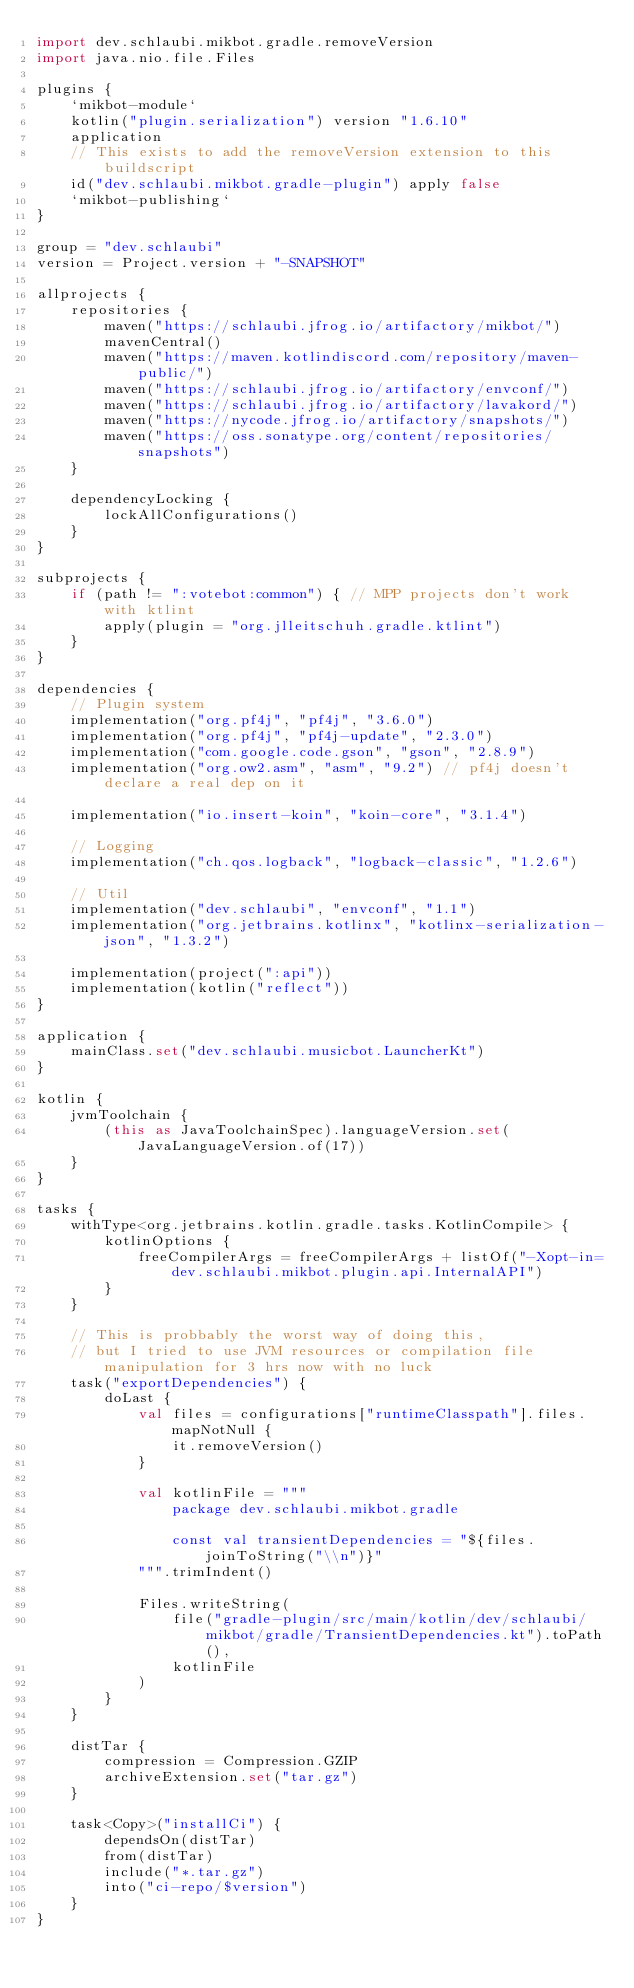<code> <loc_0><loc_0><loc_500><loc_500><_Kotlin_>import dev.schlaubi.mikbot.gradle.removeVersion
import java.nio.file.Files

plugins {
    `mikbot-module`
    kotlin("plugin.serialization") version "1.6.10"
    application
    // This exists to add the removeVersion extension to this buildscript
    id("dev.schlaubi.mikbot.gradle-plugin") apply false
    `mikbot-publishing`
}

group = "dev.schlaubi"
version = Project.version + "-SNAPSHOT"

allprojects {
    repositories {
        maven("https://schlaubi.jfrog.io/artifactory/mikbot/")
        mavenCentral()
        maven("https://maven.kotlindiscord.com/repository/maven-public/")
        maven("https://schlaubi.jfrog.io/artifactory/envconf/")
        maven("https://schlaubi.jfrog.io/artifactory/lavakord/")
        maven("https://nycode.jfrog.io/artifactory/snapshots/")
        maven("https://oss.sonatype.org/content/repositories/snapshots")
    }

    dependencyLocking {
        lockAllConfigurations()
    }
}

subprojects {
    if (path != ":votebot:common") { // MPP projects don't work with ktlint
        apply(plugin = "org.jlleitschuh.gradle.ktlint")
    }
}

dependencies {
    // Plugin system
    implementation("org.pf4j", "pf4j", "3.6.0")
    implementation("org.pf4j", "pf4j-update", "2.3.0")
    implementation("com.google.code.gson", "gson", "2.8.9")
    implementation("org.ow2.asm", "asm", "9.2") // pf4j doesn't declare a real dep on it

    implementation("io.insert-koin", "koin-core", "3.1.4")

    // Logging
    implementation("ch.qos.logback", "logback-classic", "1.2.6")

    // Util
    implementation("dev.schlaubi", "envconf", "1.1")
    implementation("org.jetbrains.kotlinx", "kotlinx-serialization-json", "1.3.2")

    implementation(project(":api"))
    implementation(kotlin("reflect"))
}

application {
    mainClass.set("dev.schlaubi.musicbot.LauncherKt")
}

kotlin {
    jvmToolchain {
        (this as JavaToolchainSpec).languageVersion.set(JavaLanguageVersion.of(17))
    }
}

tasks {
    withType<org.jetbrains.kotlin.gradle.tasks.KotlinCompile> {
        kotlinOptions {
            freeCompilerArgs = freeCompilerArgs + listOf("-Xopt-in=dev.schlaubi.mikbot.plugin.api.InternalAPI")
        }
    }

    // This is probbably the worst way of doing this,
    // but I tried to use JVM resources or compilation file manipulation for 3 hrs now with no luck
    task("exportDependencies") {
        doLast {
            val files = configurations["runtimeClasspath"].files.mapNotNull {
                it.removeVersion()
            }

            val kotlinFile = """
                package dev.schlaubi.mikbot.gradle
                
                const val transientDependencies = "${files.joinToString("\\n")}"
            """.trimIndent()

            Files.writeString(
                file("gradle-plugin/src/main/kotlin/dev/schlaubi/mikbot/gradle/TransientDependencies.kt").toPath(),
                kotlinFile
            )
        }
    }

    distTar {
        compression = Compression.GZIP
        archiveExtension.set("tar.gz")
    }

    task<Copy>("installCi") {
        dependsOn(distTar)
        from(distTar)
        include("*.tar.gz")
        into("ci-repo/$version")
    }
}
</code> 